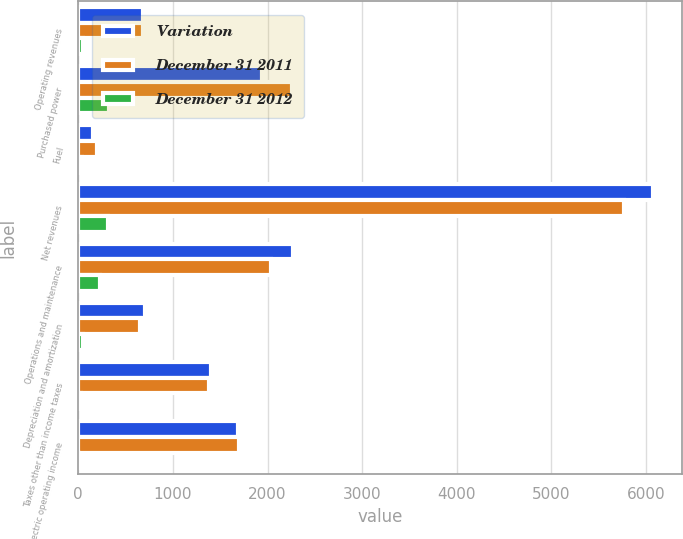Convert chart. <chart><loc_0><loc_0><loc_500><loc_500><stacked_bar_chart><ecel><fcel>Operating revenues<fcel>Purchased power<fcel>Fuel<fcel>Net revenues<fcel>Operations and maintenance<fcel>Depreciation and amortization<fcel>Taxes other than income taxes<fcel>Electric operating income<nl><fcel>Variation<fcel>683<fcel>1938<fcel>159<fcel>6079<fcel>2273<fcel>710<fcel>1403<fcel>1693<nl><fcel>December 31 2011<fcel>683<fcel>2260<fcel>199<fcel>5769<fcel>2041<fcel>656<fcel>1377<fcel>1695<nl><fcel>December 31 2012<fcel>52<fcel>322<fcel>40<fcel>310<fcel>232<fcel>54<fcel>26<fcel>2<nl></chart> 